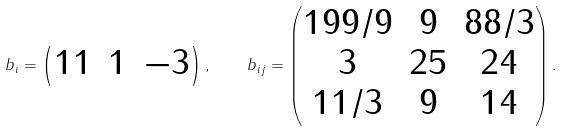Convert formula to latex. <formula><loc_0><loc_0><loc_500><loc_500>b _ { i } = \begin{pmatrix} 1 1 & 1 & - 3 \end{pmatrix} , \quad b _ { i j } = \begin{pmatrix} { 1 9 9 } / { 9 } & 9 & { 8 8 } / { 3 } \\ 3 & 2 5 & 2 4 \\ { 1 1 } / { 3 } & 9 & 1 4 \end{pmatrix} .</formula> 